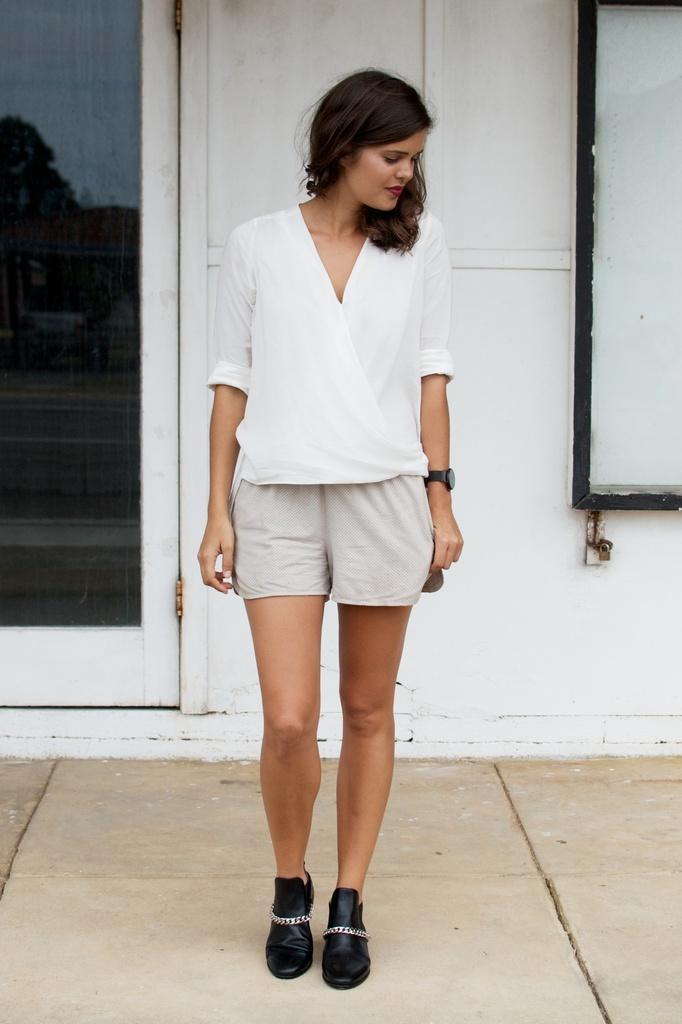In one or two sentences, can you explain what this image depicts? In this image we can see a woman is standing on the floor. She is wearing a white color dress. In the background, we can see a wall and a door. 